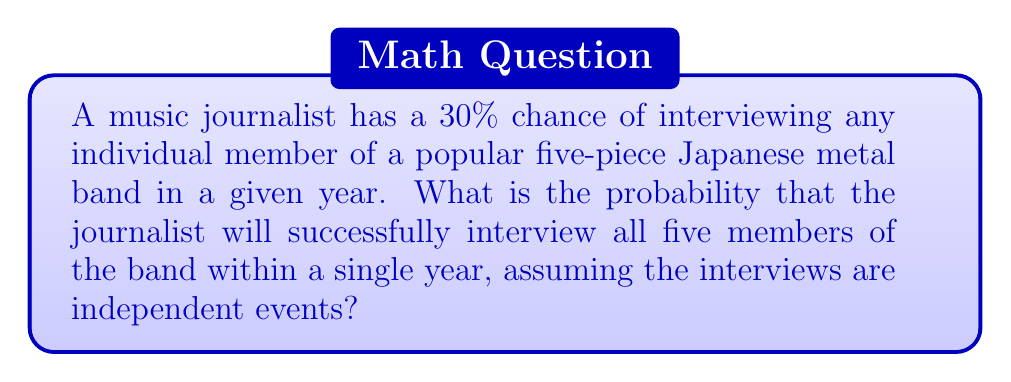Show me your answer to this math problem. Let's approach this step-by-step:

1) The probability of interviewing each member is 30% or 0.3.

2) We need to find the probability of interviewing all five members, which means we need the probability of five independent successful events occurring.

3) When we have independent events and we want all of them to occur, we multiply their individual probabilities.

4) Therefore, the probability of interviewing all five members is:

   $$P(\text{all five}) = 0.3 \times 0.3 \times 0.3 \times 0.3 \times 0.3 = 0.3^5$$

5) Let's calculate this:

   $$0.3^5 = 0.00243$$

6) To convert to a percentage, we multiply by 100:

   $$0.00243 \times 100 = 0.243\%$$

Thus, the probability of the music journalist interviewing all five members of the Japanese metal band in a single year is approximately 0.243% or about 1 in 412 chances.
Answer: $0.243\%$ 